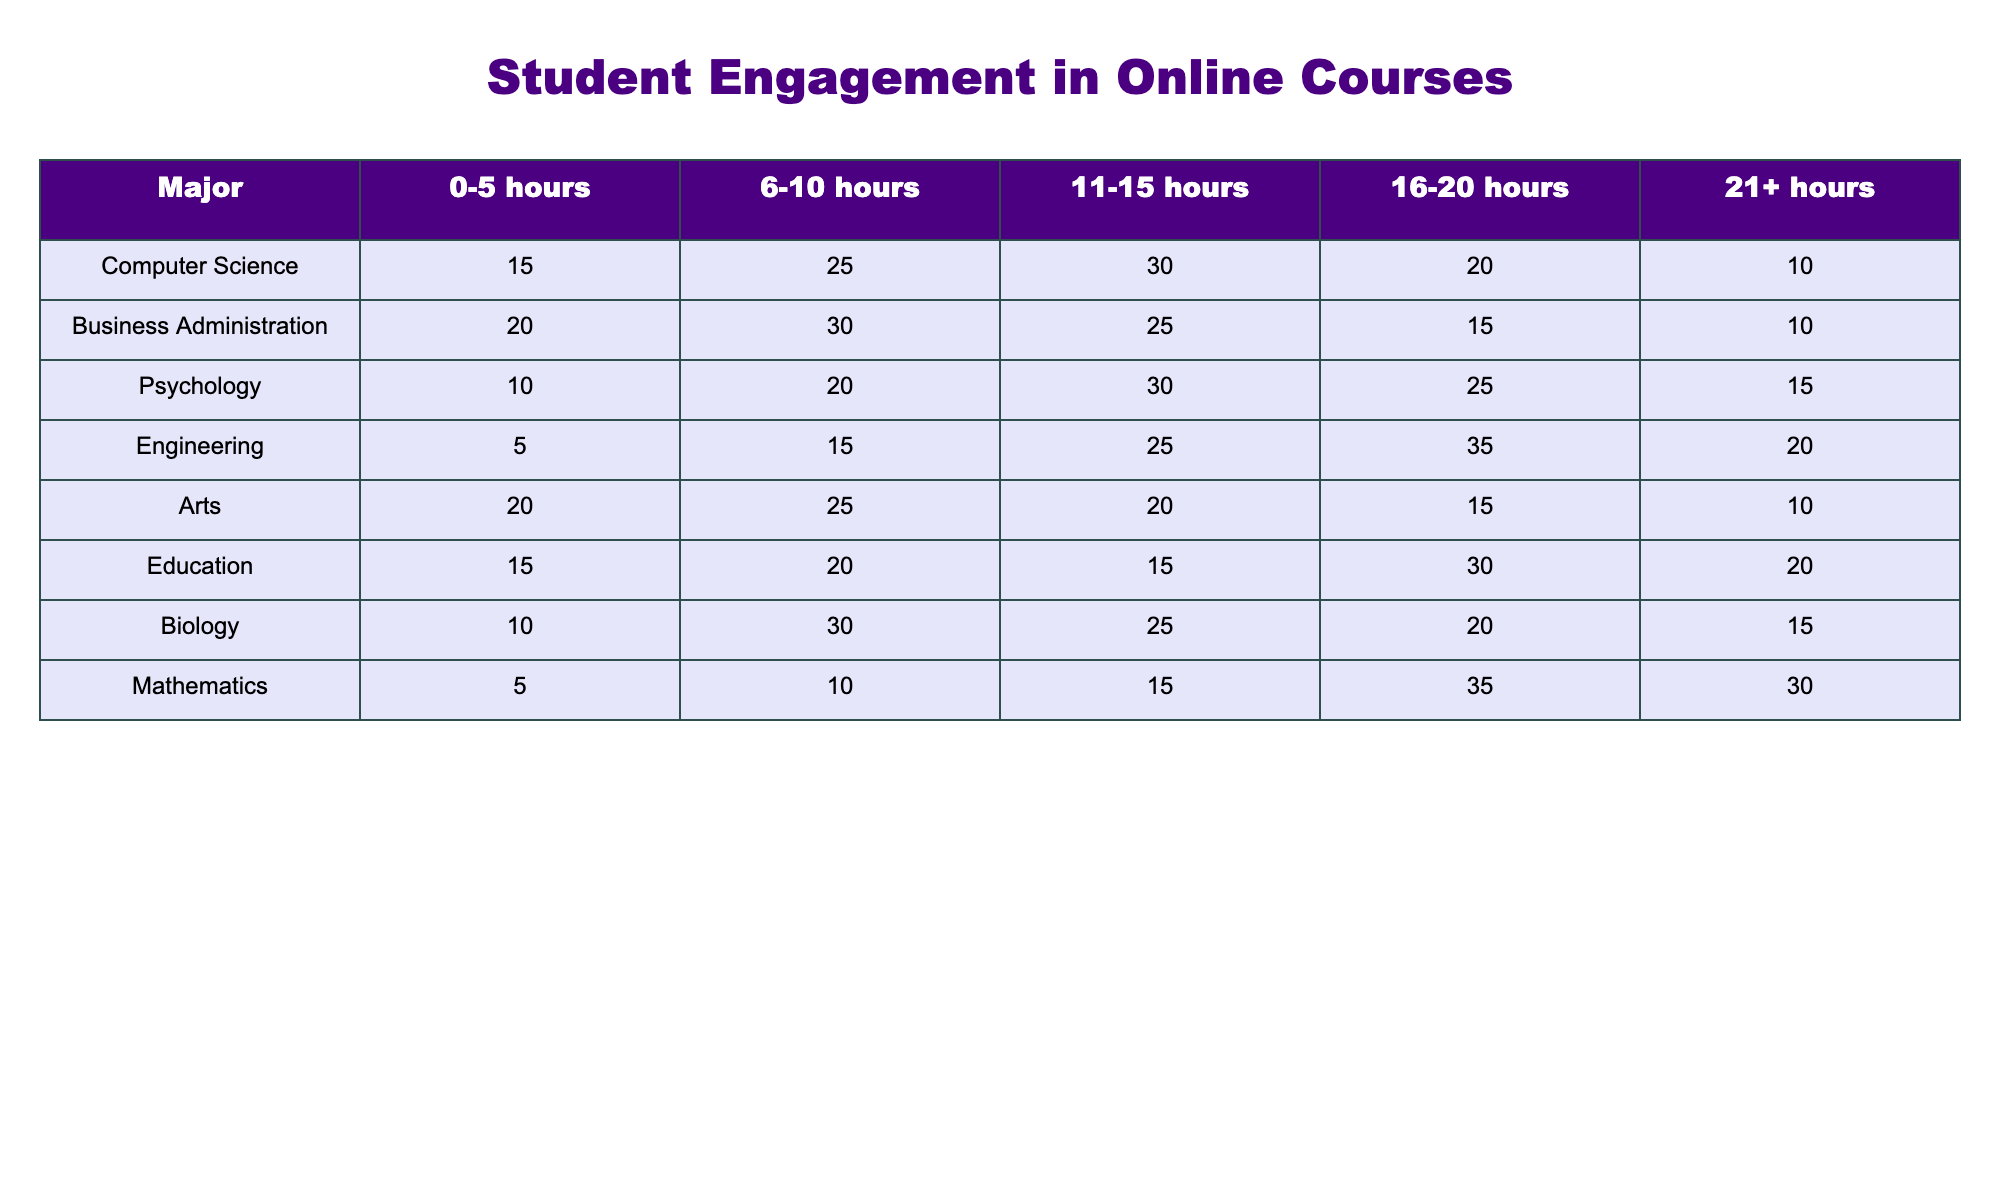What major has the highest engagement for 16-20 hours? By looking at the 16-20 hours column in the table, Engineering has the highest value at 35.
Answer: Engineering What is the total number of students studying 21+ hours in Biology and Psychology combined? For Biology, the number of students studying 21+ hours is 15, and for Psychology, it is also 15. Adding these gives 15 + 15 = 30.
Answer: 30 Do more students in Mathematics study for 0-5 hours than in Computer Science? Mathematics has 5 students studying for 0-5 hours, while Computer Science has 15. Since 5 is less than 15, the answer is no.
Answer: No What is the average number of students studying 6-10 hours across all majors? First, we find the total in the 6-10 hours column: (25 + 30 + 20 + 15 + 25 + 20 + 30 + 10) = 175. There are 8 majors, so the average is 175/8 = 21.875.
Answer: 21.875 Is it true that Education has a higher number of students studying for 11-15 hours than Arts? Education has 15 students in the 11-15 hours category, while Arts has 20 students. Since 15 is less than 20, the statement is false.
Answer: False Which major has the lowest total engagement across all time spent studying? By summing the total values for each major: Computer Science (15+25+30+20+10 = 100), Business Administration (20+30+25+15+10 = 110), Psychology (10+20+30+25+15 = 110), Engineering (5+15+25+35+20 = 100), Arts (20+25+20+15+10 = 100), Education (15+20+15+30+20 = 100), Biology (10+30+25+20+15 = 110), Mathematics (5+10+15+35+30 = 95). Mathematics has the lowest total at 95.
Answer: Mathematics How many students from Engineering study between 11-15 hours? Referring to the Engineering row, the number of students studying between 11-15 hours is 25.
Answer: 25 What is the difference in the number of students studying for 14 hours between the major with the highest engagement and the major with the lowest in that category? In the 11-15 hours category, Engineering has the highest value with 25 students, and Mathematics is the lowest with 15 students. The difference is 25 - 15 = 10.
Answer: 10 Which major has the greatest number of students in the 21+ hours category? Checking the 21+ hours column, both Computer Science and Mathematics have 10 students, but Engineering has more with 20. Thus, Engineering has the greatest number.
Answer: Engineering 